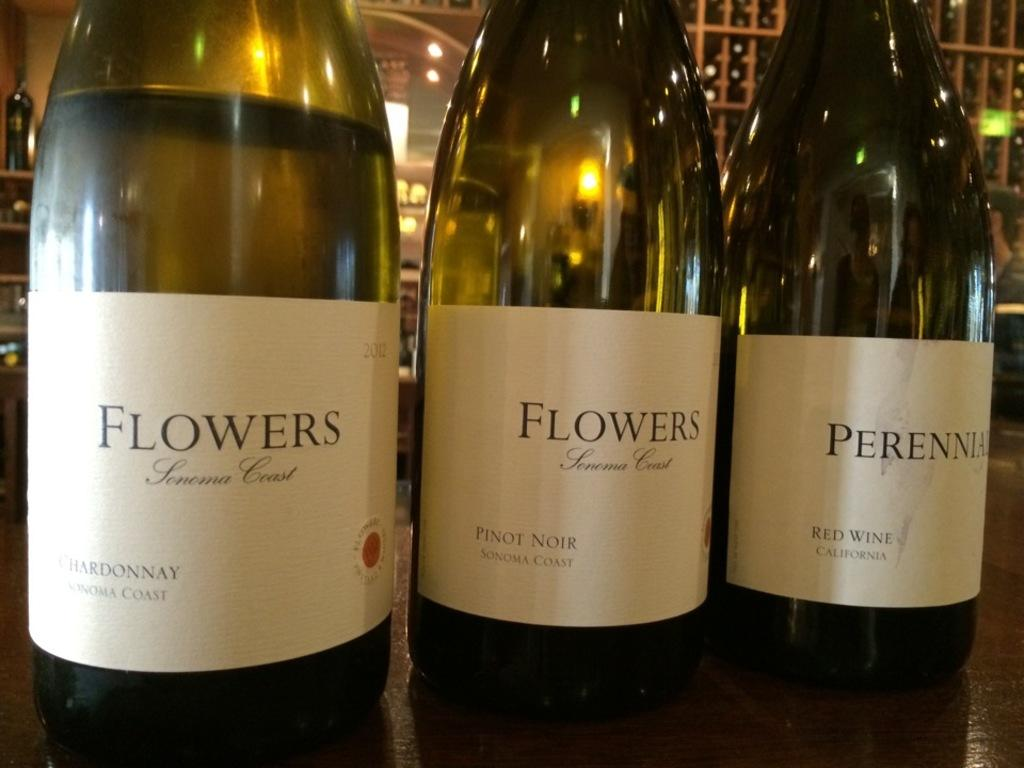<image>
Share a concise interpretation of the image provided. Sonoma Crest brand wine bottles with chardonnay, pinot noir and red wine. 